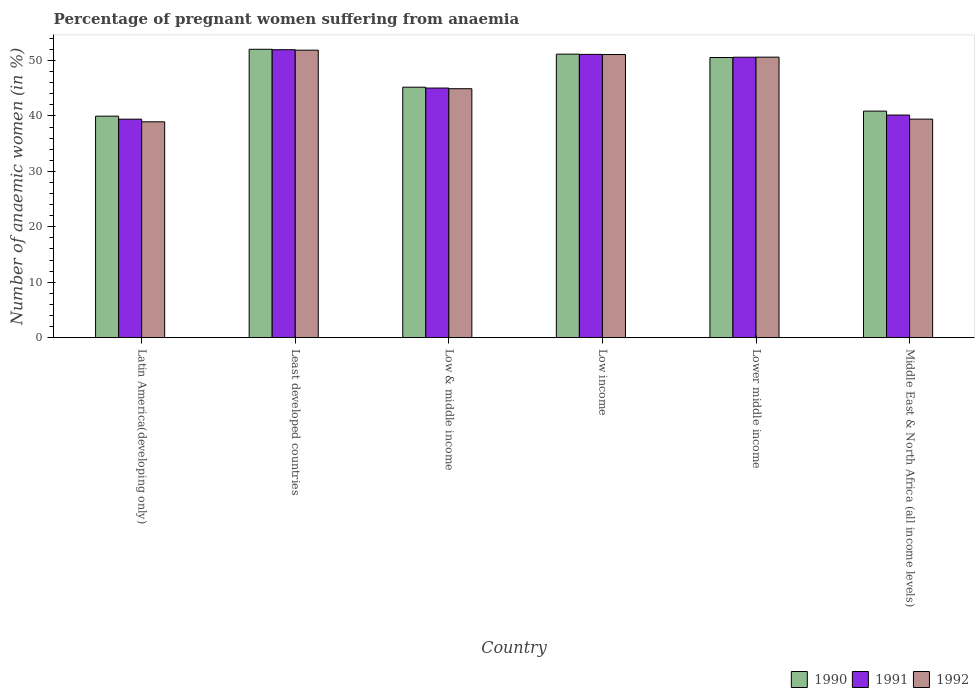Are the number of bars per tick equal to the number of legend labels?
Make the answer very short. Yes. How many bars are there on the 3rd tick from the left?
Offer a very short reply. 3. How many bars are there on the 2nd tick from the right?
Your response must be concise. 3. What is the label of the 6th group of bars from the left?
Provide a short and direct response. Middle East & North Africa (all income levels). In how many cases, is the number of bars for a given country not equal to the number of legend labels?
Your answer should be very brief. 0. What is the number of anaemic women in 1992 in Low income?
Give a very brief answer. 51.09. Across all countries, what is the maximum number of anaemic women in 1990?
Offer a terse response. 52.03. Across all countries, what is the minimum number of anaemic women in 1992?
Offer a very short reply. 38.95. In which country was the number of anaemic women in 1990 maximum?
Your response must be concise. Least developed countries. In which country was the number of anaemic women in 1991 minimum?
Your answer should be compact. Latin America(developing only). What is the total number of anaemic women in 1991 in the graph?
Give a very brief answer. 278.31. What is the difference between the number of anaemic women in 1990 in Least developed countries and that in Low & middle income?
Keep it short and to the point. 6.84. What is the difference between the number of anaemic women in 1991 in Low & middle income and the number of anaemic women in 1992 in Latin America(developing only)?
Ensure brevity in your answer.  6.09. What is the average number of anaemic women in 1991 per country?
Give a very brief answer. 46.39. What is the difference between the number of anaemic women of/in 1990 and number of anaemic women of/in 1992 in Lower middle income?
Offer a very short reply. -0.06. What is the ratio of the number of anaemic women in 1991 in Low & middle income to that in Lower middle income?
Ensure brevity in your answer.  0.89. What is the difference between the highest and the second highest number of anaemic women in 1992?
Your answer should be very brief. 0.47. What is the difference between the highest and the lowest number of anaemic women in 1990?
Ensure brevity in your answer.  12.07. In how many countries, is the number of anaemic women in 1991 greater than the average number of anaemic women in 1991 taken over all countries?
Make the answer very short. 3. Is the sum of the number of anaemic women in 1991 in Low income and Middle East & North Africa (all income levels) greater than the maximum number of anaemic women in 1992 across all countries?
Give a very brief answer. Yes. What does the 3rd bar from the right in Least developed countries represents?
Provide a succinct answer. 1990. Does the graph contain grids?
Provide a succinct answer. No. Where does the legend appear in the graph?
Make the answer very short. Bottom right. How many legend labels are there?
Give a very brief answer. 3. What is the title of the graph?
Offer a very short reply. Percentage of pregnant women suffering from anaemia. Does "1993" appear as one of the legend labels in the graph?
Offer a terse response. No. What is the label or title of the X-axis?
Give a very brief answer. Country. What is the label or title of the Y-axis?
Keep it short and to the point. Number of anaemic women (in %). What is the Number of anaemic women (in %) in 1990 in Latin America(developing only)?
Keep it short and to the point. 39.97. What is the Number of anaemic women (in %) in 1991 in Latin America(developing only)?
Provide a succinct answer. 39.43. What is the Number of anaemic women (in %) in 1992 in Latin America(developing only)?
Your response must be concise. 38.95. What is the Number of anaemic women (in %) in 1990 in Least developed countries?
Provide a succinct answer. 52.03. What is the Number of anaemic women (in %) in 1991 in Least developed countries?
Ensure brevity in your answer.  51.96. What is the Number of anaemic women (in %) of 1992 in Least developed countries?
Offer a very short reply. 51.88. What is the Number of anaemic women (in %) of 1990 in Low & middle income?
Keep it short and to the point. 45.2. What is the Number of anaemic women (in %) of 1991 in Low & middle income?
Provide a succinct answer. 45.04. What is the Number of anaemic women (in %) in 1992 in Low & middle income?
Your response must be concise. 44.92. What is the Number of anaemic women (in %) of 1990 in Low income?
Give a very brief answer. 51.16. What is the Number of anaemic women (in %) of 1991 in Low income?
Your response must be concise. 51.12. What is the Number of anaemic women (in %) in 1992 in Low income?
Your response must be concise. 51.09. What is the Number of anaemic women (in %) of 1990 in Lower middle income?
Ensure brevity in your answer.  50.55. What is the Number of anaemic women (in %) in 1991 in Lower middle income?
Give a very brief answer. 50.6. What is the Number of anaemic women (in %) in 1992 in Lower middle income?
Your answer should be very brief. 50.62. What is the Number of anaemic women (in %) in 1990 in Middle East & North Africa (all income levels)?
Provide a succinct answer. 40.88. What is the Number of anaemic women (in %) of 1991 in Middle East & North Africa (all income levels)?
Ensure brevity in your answer.  40.17. What is the Number of anaemic women (in %) of 1992 in Middle East & North Africa (all income levels)?
Your answer should be very brief. 39.43. Across all countries, what is the maximum Number of anaemic women (in %) in 1990?
Offer a very short reply. 52.03. Across all countries, what is the maximum Number of anaemic women (in %) in 1991?
Give a very brief answer. 51.96. Across all countries, what is the maximum Number of anaemic women (in %) in 1992?
Keep it short and to the point. 51.88. Across all countries, what is the minimum Number of anaemic women (in %) in 1990?
Give a very brief answer. 39.97. Across all countries, what is the minimum Number of anaemic women (in %) in 1991?
Offer a terse response. 39.43. Across all countries, what is the minimum Number of anaemic women (in %) in 1992?
Keep it short and to the point. 38.95. What is the total Number of anaemic women (in %) of 1990 in the graph?
Your answer should be compact. 279.79. What is the total Number of anaemic women (in %) in 1991 in the graph?
Provide a short and direct response. 278.31. What is the total Number of anaemic women (in %) in 1992 in the graph?
Offer a terse response. 276.88. What is the difference between the Number of anaemic women (in %) in 1990 in Latin America(developing only) and that in Least developed countries?
Give a very brief answer. -12.07. What is the difference between the Number of anaemic women (in %) in 1991 in Latin America(developing only) and that in Least developed countries?
Keep it short and to the point. -12.53. What is the difference between the Number of anaemic women (in %) of 1992 in Latin America(developing only) and that in Least developed countries?
Your response must be concise. -12.92. What is the difference between the Number of anaemic women (in %) in 1990 in Latin America(developing only) and that in Low & middle income?
Offer a very short reply. -5.23. What is the difference between the Number of anaemic women (in %) of 1991 in Latin America(developing only) and that in Low & middle income?
Your answer should be compact. -5.61. What is the difference between the Number of anaemic women (in %) in 1992 in Latin America(developing only) and that in Low & middle income?
Provide a succinct answer. -5.97. What is the difference between the Number of anaemic women (in %) in 1990 in Latin America(developing only) and that in Low income?
Ensure brevity in your answer.  -11.19. What is the difference between the Number of anaemic women (in %) of 1991 in Latin America(developing only) and that in Low income?
Your response must be concise. -11.69. What is the difference between the Number of anaemic women (in %) of 1992 in Latin America(developing only) and that in Low income?
Keep it short and to the point. -12.14. What is the difference between the Number of anaemic women (in %) in 1990 in Latin America(developing only) and that in Lower middle income?
Provide a short and direct response. -10.58. What is the difference between the Number of anaemic women (in %) in 1991 in Latin America(developing only) and that in Lower middle income?
Your response must be concise. -11.18. What is the difference between the Number of anaemic women (in %) of 1992 in Latin America(developing only) and that in Lower middle income?
Give a very brief answer. -11.67. What is the difference between the Number of anaemic women (in %) of 1990 in Latin America(developing only) and that in Middle East & North Africa (all income levels)?
Your response must be concise. -0.91. What is the difference between the Number of anaemic women (in %) of 1991 in Latin America(developing only) and that in Middle East & North Africa (all income levels)?
Offer a terse response. -0.74. What is the difference between the Number of anaemic women (in %) of 1992 in Latin America(developing only) and that in Middle East & North Africa (all income levels)?
Offer a very short reply. -0.48. What is the difference between the Number of anaemic women (in %) in 1990 in Least developed countries and that in Low & middle income?
Your answer should be very brief. 6.84. What is the difference between the Number of anaemic women (in %) of 1991 in Least developed countries and that in Low & middle income?
Give a very brief answer. 6.92. What is the difference between the Number of anaemic women (in %) of 1992 in Least developed countries and that in Low & middle income?
Your answer should be very brief. 6.96. What is the difference between the Number of anaemic women (in %) in 1990 in Least developed countries and that in Low income?
Offer a terse response. 0.88. What is the difference between the Number of anaemic women (in %) in 1991 in Least developed countries and that in Low income?
Offer a terse response. 0.84. What is the difference between the Number of anaemic women (in %) of 1992 in Least developed countries and that in Low income?
Offer a terse response. 0.79. What is the difference between the Number of anaemic women (in %) in 1990 in Least developed countries and that in Lower middle income?
Offer a very short reply. 1.48. What is the difference between the Number of anaemic women (in %) in 1991 in Least developed countries and that in Lower middle income?
Your answer should be very brief. 1.35. What is the difference between the Number of anaemic women (in %) in 1992 in Least developed countries and that in Lower middle income?
Provide a short and direct response. 1.26. What is the difference between the Number of anaemic women (in %) of 1990 in Least developed countries and that in Middle East & North Africa (all income levels)?
Provide a short and direct response. 11.15. What is the difference between the Number of anaemic women (in %) in 1991 in Least developed countries and that in Middle East & North Africa (all income levels)?
Your response must be concise. 11.79. What is the difference between the Number of anaemic women (in %) of 1992 in Least developed countries and that in Middle East & North Africa (all income levels)?
Offer a terse response. 12.44. What is the difference between the Number of anaemic women (in %) in 1990 in Low & middle income and that in Low income?
Your answer should be compact. -5.96. What is the difference between the Number of anaemic women (in %) in 1991 in Low & middle income and that in Low income?
Offer a very short reply. -6.08. What is the difference between the Number of anaemic women (in %) in 1992 in Low & middle income and that in Low income?
Ensure brevity in your answer.  -6.17. What is the difference between the Number of anaemic women (in %) of 1990 in Low & middle income and that in Lower middle income?
Offer a terse response. -5.36. What is the difference between the Number of anaemic women (in %) of 1991 in Low & middle income and that in Lower middle income?
Your answer should be very brief. -5.56. What is the difference between the Number of anaemic women (in %) in 1992 in Low & middle income and that in Lower middle income?
Make the answer very short. -5.7. What is the difference between the Number of anaemic women (in %) of 1990 in Low & middle income and that in Middle East & North Africa (all income levels)?
Give a very brief answer. 4.32. What is the difference between the Number of anaemic women (in %) of 1991 in Low & middle income and that in Middle East & North Africa (all income levels)?
Provide a succinct answer. 4.87. What is the difference between the Number of anaemic women (in %) of 1992 in Low & middle income and that in Middle East & North Africa (all income levels)?
Offer a terse response. 5.49. What is the difference between the Number of anaemic women (in %) in 1990 in Low income and that in Lower middle income?
Your answer should be compact. 0.6. What is the difference between the Number of anaemic women (in %) of 1991 in Low income and that in Lower middle income?
Your response must be concise. 0.51. What is the difference between the Number of anaemic women (in %) in 1992 in Low income and that in Lower middle income?
Ensure brevity in your answer.  0.47. What is the difference between the Number of anaemic women (in %) of 1990 in Low income and that in Middle East & North Africa (all income levels)?
Provide a succinct answer. 10.28. What is the difference between the Number of anaemic women (in %) in 1991 in Low income and that in Middle East & North Africa (all income levels)?
Provide a succinct answer. 10.95. What is the difference between the Number of anaemic women (in %) in 1992 in Low income and that in Middle East & North Africa (all income levels)?
Your answer should be very brief. 11.66. What is the difference between the Number of anaemic women (in %) of 1990 in Lower middle income and that in Middle East & North Africa (all income levels)?
Offer a terse response. 9.67. What is the difference between the Number of anaemic women (in %) of 1991 in Lower middle income and that in Middle East & North Africa (all income levels)?
Give a very brief answer. 10.44. What is the difference between the Number of anaemic women (in %) of 1992 in Lower middle income and that in Middle East & North Africa (all income levels)?
Provide a succinct answer. 11.19. What is the difference between the Number of anaemic women (in %) in 1990 in Latin America(developing only) and the Number of anaemic women (in %) in 1991 in Least developed countries?
Make the answer very short. -11.99. What is the difference between the Number of anaemic women (in %) in 1990 in Latin America(developing only) and the Number of anaemic women (in %) in 1992 in Least developed countries?
Ensure brevity in your answer.  -11.91. What is the difference between the Number of anaemic women (in %) in 1991 in Latin America(developing only) and the Number of anaemic women (in %) in 1992 in Least developed countries?
Keep it short and to the point. -12.45. What is the difference between the Number of anaemic women (in %) in 1990 in Latin America(developing only) and the Number of anaemic women (in %) in 1991 in Low & middle income?
Your answer should be compact. -5.07. What is the difference between the Number of anaemic women (in %) in 1990 in Latin America(developing only) and the Number of anaemic women (in %) in 1992 in Low & middle income?
Offer a very short reply. -4.95. What is the difference between the Number of anaemic women (in %) in 1991 in Latin America(developing only) and the Number of anaemic women (in %) in 1992 in Low & middle income?
Your answer should be compact. -5.49. What is the difference between the Number of anaemic women (in %) in 1990 in Latin America(developing only) and the Number of anaemic women (in %) in 1991 in Low income?
Give a very brief answer. -11.15. What is the difference between the Number of anaemic women (in %) of 1990 in Latin America(developing only) and the Number of anaemic women (in %) of 1992 in Low income?
Make the answer very short. -11.12. What is the difference between the Number of anaemic women (in %) of 1991 in Latin America(developing only) and the Number of anaemic women (in %) of 1992 in Low income?
Your response must be concise. -11.66. What is the difference between the Number of anaemic women (in %) in 1990 in Latin America(developing only) and the Number of anaemic women (in %) in 1991 in Lower middle income?
Provide a succinct answer. -10.63. What is the difference between the Number of anaemic women (in %) in 1990 in Latin America(developing only) and the Number of anaemic women (in %) in 1992 in Lower middle income?
Provide a short and direct response. -10.65. What is the difference between the Number of anaemic women (in %) of 1991 in Latin America(developing only) and the Number of anaemic women (in %) of 1992 in Lower middle income?
Your answer should be compact. -11.19. What is the difference between the Number of anaemic women (in %) of 1990 in Latin America(developing only) and the Number of anaemic women (in %) of 1991 in Middle East & North Africa (all income levels)?
Offer a terse response. -0.2. What is the difference between the Number of anaemic women (in %) in 1990 in Latin America(developing only) and the Number of anaemic women (in %) in 1992 in Middle East & North Africa (all income levels)?
Give a very brief answer. 0.54. What is the difference between the Number of anaemic women (in %) of 1991 in Latin America(developing only) and the Number of anaemic women (in %) of 1992 in Middle East & North Africa (all income levels)?
Offer a very short reply. -0.01. What is the difference between the Number of anaemic women (in %) in 1990 in Least developed countries and the Number of anaemic women (in %) in 1991 in Low & middle income?
Ensure brevity in your answer.  6.99. What is the difference between the Number of anaemic women (in %) in 1990 in Least developed countries and the Number of anaemic women (in %) in 1992 in Low & middle income?
Ensure brevity in your answer.  7.12. What is the difference between the Number of anaemic women (in %) in 1991 in Least developed countries and the Number of anaemic women (in %) in 1992 in Low & middle income?
Give a very brief answer. 7.04. What is the difference between the Number of anaemic women (in %) in 1990 in Least developed countries and the Number of anaemic women (in %) in 1991 in Low income?
Offer a very short reply. 0.92. What is the difference between the Number of anaemic women (in %) in 1990 in Least developed countries and the Number of anaemic women (in %) in 1992 in Low income?
Ensure brevity in your answer.  0.95. What is the difference between the Number of anaemic women (in %) of 1991 in Least developed countries and the Number of anaemic women (in %) of 1992 in Low income?
Your response must be concise. 0.87. What is the difference between the Number of anaemic women (in %) of 1990 in Least developed countries and the Number of anaemic women (in %) of 1991 in Lower middle income?
Your response must be concise. 1.43. What is the difference between the Number of anaemic women (in %) in 1990 in Least developed countries and the Number of anaemic women (in %) in 1992 in Lower middle income?
Offer a terse response. 1.42. What is the difference between the Number of anaemic women (in %) in 1991 in Least developed countries and the Number of anaemic women (in %) in 1992 in Lower middle income?
Your answer should be very brief. 1.34. What is the difference between the Number of anaemic women (in %) of 1990 in Least developed countries and the Number of anaemic women (in %) of 1991 in Middle East & North Africa (all income levels)?
Your answer should be very brief. 11.87. What is the difference between the Number of anaemic women (in %) of 1990 in Least developed countries and the Number of anaemic women (in %) of 1992 in Middle East & North Africa (all income levels)?
Your response must be concise. 12.6. What is the difference between the Number of anaemic women (in %) in 1991 in Least developed countries and the Number of anaemic women (in %) in 1992 in Middle East & North Africa (all income levels)?
Offer a very short reply. 12.53. What is the difference between the Number of anaemic women (in %) of 1990 in Low & middle income and the Number of anaemic women (in %) of 1991 in Low income?
Provide a succinct answer. -5.92. What is the difference between the Number of anaemic women (in %) in 1990 in Low & middle income and the Number of anaemic women (in %) in 1992 in Low income?
Your answer should be compact. -5.89. What is the difference between the Number of anaemic women (in %) in 1991 in Low & middle income and the Number of anaemic women (in %) in 1992 in Low income?
Provide a succinct answer. -6.05. What is the difference between the Number of anaemic women (in %) of 1990 in Low & middle income and the Number of anaemic women (in %) of 1991 in Lower middle income?
Ensure brevity in your answer.  -5.41. What is the difference between the Number of anaemic women (in %) in 1990 in Low & middle income and the Number of anaemic women (in %) in 1992 in Lower middle income?
Provide a short and direct response. -5.42. What is the difference between the Number of anaemic women (in %) of 1991 in Low & middle income and the Number of anaemic women (in %) of 1992 in Lower middle income?
Offer a terse response. -5.58. What is the difference between the Number of anaemic women (in %) in 1990 in Low & middle income and the Number of anaemic women (in %) in 1991 in Middle East & North Africa (all income levels)?
Give a very brief answer. 5.03. What is the difference between the Number of anaemic women (in %) in 1990 in Low & middle income and the Number of anaemic women (in %) in 1992 in Middle East & North Africa (all income levels)?
Keep it short and to the point. 5.76. What is the difference between the Number of anaemic women (in %) in 1991 in Low & middle income and the Number of anaemic women (in %) in 1992 in Middle East & North Africa (all income levels)?
Offer a terse response. 5.61. What is the difference between the Number of anaemic women (in %) in 1990 in Low income and the Number of anaemic women (in %) in 1991 in Lower middle income?
Provide a succinct answer. 0.55. What is the difference between the Number of anaemic women (in %) in 1990 in Low income and the Number of anaemic women (in %) in 1992 in Lower middle income?
Provide a succinct answer. 0.54. What is the difference between the Number of anaemic women (in %) in 1991 in Low income and the Number of anaemic women (in %) in 1992 in Lower middle income?
Provide a succinct answer. 0.5. What is the difference between the Number of anaemic women (in %) of 1990 in Low income and the Number of anaemic women (in %) of 1991 in Middle East & North Africa (all income levels)?
Make the answer very short. 10.99. What is the difference between the Number of anaemic women (in %) in 1990 in Low income and the Number of anaemic women (in %) in 1992 in Middle East & North Africa (all income levels)?
Offer a very short reply. 11.73. What is the difference between the Number of anaemic women (in %) in 1991 in Low income and the Number of anaemic women (in %) in 1992 in Middle East & North Africa (all income levels)?
Offer a very short reply. 11.68. What is the difference between the Number of anaemic women (in %) of 1990 in Lower middle income and the Number of anaemic women (in %) of 1991 in Middle East & North Africa (all income levels)?
Your answer should be very brief. 10.39. What is the difference between the Number of anaemic women (in %) in 1990 in Lower middle income and the Number of anaemic women (in %) in 1992 in Middle East & North Africa (all income levels)?
Give a very brief answer. 11.12. What is the difference between the Number of anaemic women (in %) in 1991 in Lower middle income and the Number of anaemic women (in %) in 1992 in Middle East & North Africa (all income levels)?
Provide a succinct answer. 11.17. What is the average Number of anaemic women (in %) of 1990 per country?
Your answer should be very brief. 46.63. What is the average Number of anaemic women (in %) in 1991 per country?
Give a very brief answer. 46.38. What is the average Number of anaemic women (in %) in 1992 per country?
Provide a short and direct response. 46.15. What is the difference between the Number of anaemic women (in %) in 1990 and Number of anaemic women (in %) in 1991 in Latin America(developing only)?
Your response must be concise. 0.54. What is the difference between the Number of anaemic women (in %) of 1991 and Number of anaemic women (in %) of 1992 in Latin America(developing only)?
Ensure brevity in your answer.  0.48. What is the difference between the Number of anaemic women (in %) of 1990 and Number of anaemic women (in %) of 1991 in Least developed countries?
Ensure brevity in your answer.  0.08. What is the difference between the Number of anaemic women (in %) of 1990 and Number of anaemic women (in %) of 1992 in Least developed countries?
Provide a succinct answer. 0.16. What is the difference between the Number of anaemic women (in %) in 1991 and Number of anaemic women (in %) in 1992 in Least developed countries?
Offer a very short reply. 0.08. What is the difference between the Number of anaemic women (in %) of 1990 and Number of anaemic women (in %) of 1991 in Low & middle income?
Provide a short and direct response. 0.16. What is the difference between the Number of anaemic women (in %) of 1990 and Number of anaemic women (in %) of 1992 in Low & middle income?
Provide a short and direct response. 0.28. What is the difference between the Number of anaemic women (in %) of 1991 and Number of anaemic women (in %) of 1992 in Low & middle income?
Offer a very short reply. 0.12. What is the difference between the Number of anaemic women (in %) of 1990 and Number of anaemic women (in %) of 1991 in Low income?
Your answer should be very brief. 0.04. What is the difference between the Number of anaemic women (in %) of 1990 and Number of anaemic women (in %) of 1992 in Low income?
Provide a short and direct response. 0.07. What is the difference between the Number of anaemic women (in %) in 1991 and Number of anaemic women (in %) in 1992 in Low income?
Your response must be concise. 0.03. What is the difference between the Number of anaemic women (in %) of 1990 and Number of anaemic women (in %) of 1991 in Lower middle income?
Your answer should be very brief. -0.05. What is the difference between the Number of anaemic women (in %) of 1990 and Number of anaemic women (in %) of 1992 in Lower middle income?
Provide a succinct answer. -0.06. What is the difference between the Number of anaemic women (in %) in 1991 and Number of anaemic women (in %) in 1992 in Lower middle income?
Your answer should be compact. -0.01. What is the difference between the Number of anaemic women (in %) in 1990 and Number of anaemic women (in %) in 1991 in Middle East & North Africa (all income levels)?
Provide a short and direct response. 0.71. What is the difference between the Number of anaemic women (in %) in 1990 and Number of anaemic women (in %) in 1992 in Middle East & North Africa (all income levels)?
Make the answer very short. 1.45. What is the difference between the Number of anaemic women (in %) in 1991 and Number of anaemic women (in %) in 1992 in Middle East & North Africa (all income levels)?
Offer a very short reply. 0.74. What is the ratio of the Number of anaemic women (in %) in 1990 in Latin America(developing only) to that in Least developed countries?
Give a very brief answer. 0.77. What is the ratio of the Number of anaemic women (in %) in 1991 in Latin America(developing only) to that in Least developed countries?
Give a very brief answer. 0.76. What is the ratio of the Number of anaemic women (in %) of 1992 in Latin America(developing only) to that in Least developed countries?
Your response must be concise. 0.75. What is the ratio of the Number of anaemic women (in %) of 1990 in Latin America(developing only) to that in Low & middle income?
Offer a terse response. 0.88. What is the ratio of the Number of anaemic women (in %) in 1991 in Latin America(developing only) to that in Low & middle income?
Offer a terse response. 0.88. What is the ratio of the Number of anaemic women (in %) in 1992 in Latin America(developing only) to that in Low & middle income?
Provide a succinct answer. 0.87. What is the ratio of the Number of anaemic women (in %) of 1990 in Latin America(developing only) to that in Low income?
Your response must be concise. 0.78. What is the ratio of the Number of anaemic women (in %) of 1991 in Latin America(developing only) to that in Low income?
Your answer should be compact. 0.77. What is the ratio of the Number of anaemic women (in %) of 1992 in Latin America(developing only) to that in Low income?
Offer a terse response. 0.76. What is the ratio of the Number of anaemic women (in %) in 1990 in Latin America(developing only) to that in Lower middle income?
Your response must be concise. 0.79. What is the ratio of the Number of anaemic women (in %) of 1991 in Latin America(developing only) to that in Lower middle income?
Provide a succinct answer. 0.78. What is the ratio of the Number of anaemic women (in %) in 1992 in Latin America(developing only) to that in Lower middle income?
Provide a short and direct response. 0.77. What is the ratio of the Number of anaemic women (in %) of 1990 in Latin America(developing only) to that in Middle East & North Africa (all income levels)?
Give a very brief answer. 0.98. What is the ratio of the Number of anaemic women (in %) of 1991 in Latin America(developing only) to that in Middle East & North Africa (all income levels)?
Offer a terse response. 0.98. What is the ratio of the Number of anaemic women (in %) of 1992 in Latin America(developing only) to that in Middle East & North Africa (all income levels)?
Make the answer very short. 0.99. What is the ratio of the Number of anaemic women (in %) in 1990 in Least developed countries to that in Low & middle income?
Offer a terse response. 1.15. What is the ratio of the Number of anaemic women (in %) of 1991 in Least developed countries to that in Low & middle income?
Give a very brief answer. 1.15. What is the ratio of the Number of anaemic women (in %) of 1992 in Least developed countries to that in Low & middle income?
Provide a short and direct response. 1.15. What is the ratio of the Number of anaemic women (in %) of 1990 in Least developed countries to that in Low income?
Offer a very short reply. 1.02. What is the ratio of the Number of anaemic women (in %) in 1991 in Least developed countries to that in Low income?
Ensure brevity in your answer.  1.02. What is the ratio of the Number of anaemic women (in %) of 1992 in Least developed countries to that in Low income?
Provide a succinct answer. 1.02. What is the ratio of the Number of anaemic women (in %) in 1990 in Least developed countries to that in Lower middle income?
Offer a very short reply. 1.03. What is the ratio of the Number of anaemic women (in %) in 1991 in Least developed countries to that in Lower middle income?
Offer a very short reply. 1.03. What is the ratio of the Number of anaemic women (in %) in 1992 in Least developed countries to that in Lower middle income?
Give a very brief answer. 1.02. What is the ratio of the Number of anaemic women (in %) in 1990 in Least developed countries to that in Middle East & North Africa (all income levels)?
Keep it short and to the point. 1.27. What is the ratio of the Number of anaemic women (in %) of 1991 in Least developed countries to that in Middle East & North Africa (all income levels)?
Give a very brief answer. 1.29. What is the ratio of the Number of anaemic women (in %) in 1992 in Least developed countries to that in Middle East & North Africa (all income levels)?
Ensure brevity in your answer.  1.32. What is the ratio of the Number of anaemic women (in %) of 1990 in Low & middle income to that in Low income?
Keep it short and to the point. 0.88. What is the ratio of the Number of anaemic women (in %) of 1991 in Low & middle income to that in Low income?
Provide a succinct answer. 0.88. What is the ratio of the Number of anaemic women (in %) in 1992 in Low & middle income to that in Low income?
Give a very brief answer. 0.88. What is the ratio of the Number of anaemic women (in %) of 1990 in Low & middle income to that in Lower middle income?
Ensure brevity in your answer.  0.89. What is the ratio of the Number of anaemic women (in %) of 1991 in Low & middle income to that in Lower middle income?
Keep it short and to the point. 0.89. What is the ratio of the Number of anaemic women (in %) of 1992 in Low & middle income to that in Lower middle income?
Give a very brief answer. 0.89. What is the ratio of the Number of anaemic women (in %) in 1990 in Low & middle income to that in Middle East & North Africa (all income levels)?
Keep it short and to the point. 1.11. What is the ratio of the Number of anaemic women (in %) of 1991 in Low & middle income to that in Middle East & North Africa (all income levels)?
Offer a terse response. 1.12. What is the ratio of the Number of anaemic women (in %) in 1992 in Low & middle income to that in Middle East & North Africa (all income levels)?
Ensure brevity in your answer.  1.14. What is the ratio of the Number of anaemic women (in %) in 1990 in Low income to that in Lower middle income?
Make the answer very short. 1.01. What is the ratio of the Number of anaemic women (in %) of 1991 in Low income to that in Lower middle income?
Your answer should be very brief. 1.01. What is the ratio of the Number of anaemic women (in %) in 1992 in Low income to that in Lower middle income?
Keep it short and to the point. 1.01. What is the ratio of the Number of anaemic women (in %) in 1990 in Low income to that in Middle East & North Africa (all income levels)?
Your answer should be very brief. 1.25. What is the ratio of the Number of anaemic women (in %) in 1991 in Low income to that in Middle East & North Africa (all income levels)?
Your answer should be very brief. 1.27. What is the ratio of the Number of anaemic women (in %) of 1992 in Low income to that in Middle East & North Africa (all income levels)?
Your answer should be compact. 1.3. What is the ratio of the Number of anaemic women (in %) of 1990 in Lower middle income to that in Middle East & North Africa (all income levels)?
Ensure brevity in your answer.  1.24. What is the ratio of the Number of anaemic women (in %) in 1991 in Lower middle income to that in Middle East & North Africa (all income levels)?
Your response must be concise. 1.26. What is the ratio of the Number of anaemic women (in %) in 1992 in Lower middle income to that in Middle East & North Africa (all income levels)?
Offer a very short reply. 1.28. What is the difference between the highest and the second highest Number of anaemic women (in %) of 1990?
Your response must be concise. 0.88. What is the difference between the highest and the second highest Number of anaemic women (in %) in 1991?
Your answer should be very brief. 0.84. What is the difference between the highest and the second highest Number of anaemic women (in %) of 1992?
Offer a very short reply. 0.79. What is the difference between the highest and the lowest Number of anaemic women (in %) in 1990?
Offer a very short reply. 12.07. What is the difference between the highest and the lowest Number of anaemic women (in %) of 1991?
Your response must be concise. 12.53. What is the difference between the highest and the lowest Number of anaemic women (in %) in 1992?
Offer a terse response. 12.92. 